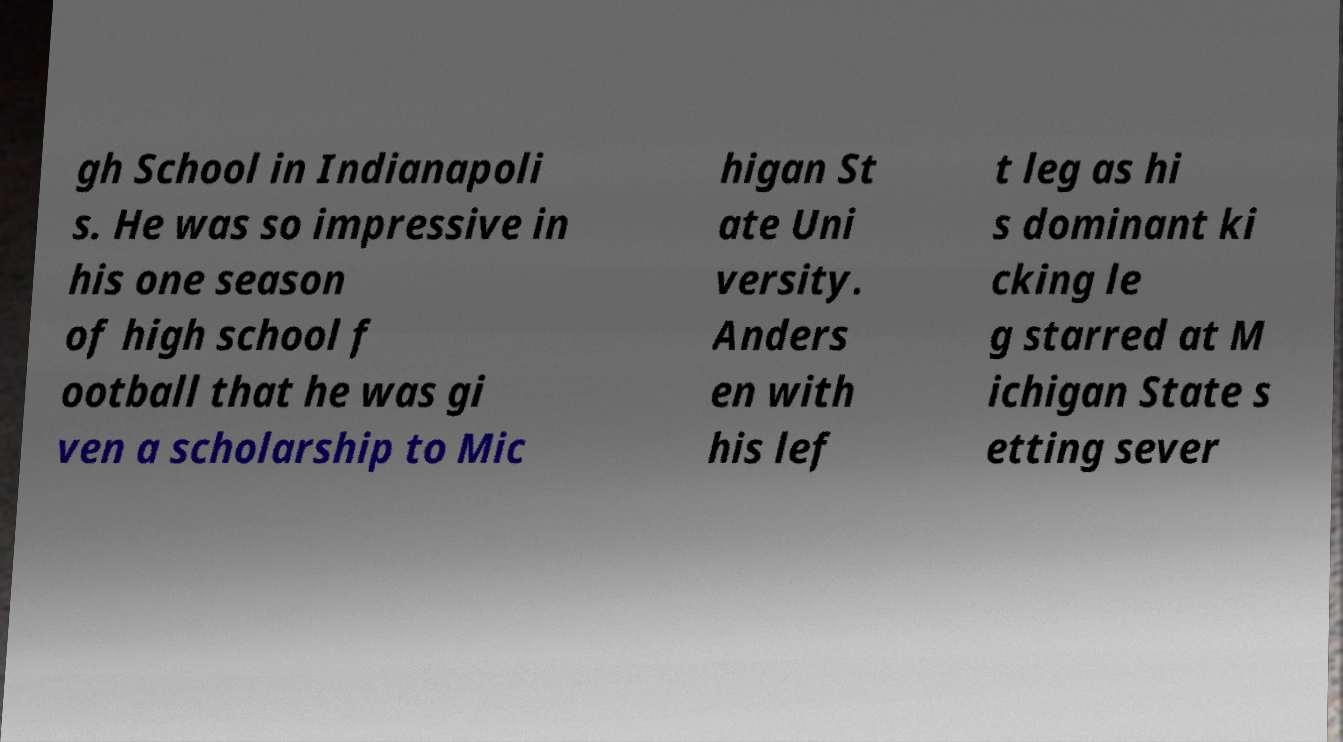Please identify and transcribe the text found in this image. gh School in Indianapoli s. He was so impressive in his one season of high school f ootball that he was gi ven a scholarship to Mic higan St ate Uni versity. Anders en with his lef t leg as hi s dominant ki cking le g starred at M ichigan State s etting sever 